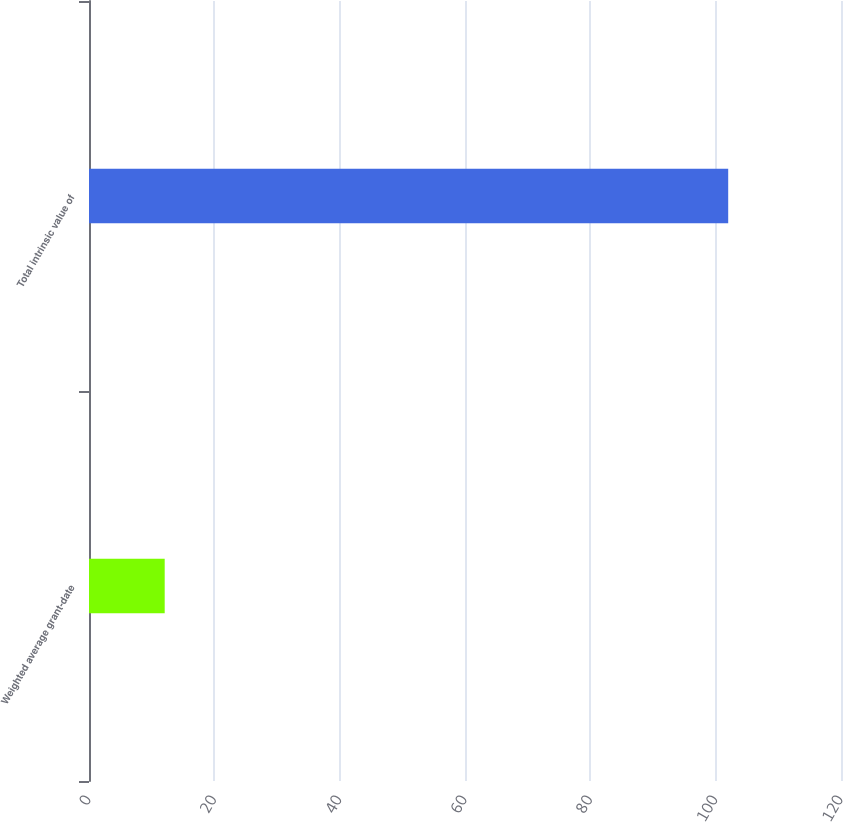<chart> <loc_0><loc_0><loc_500><loc_500><bar_chart><fcel>Weighted average grant-date<fcel>Total intrinsic value of<nl><fcel>12.08<fcel>102<nl></chart> 